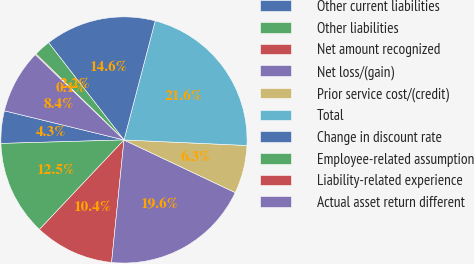Convert chart to OTSL. <chart><loc_0><loc_0><loc_500><loc_500><pie_chart><fcel>Other current liabilities<fcel>Other liabilities<fcel>Net amount recognized<fcel>Net loss/(gain)<fcel>Prior service cost/(credit)<fcel>Total<fcel>Change in discount rate<fcel>Employee-related assumption<fcel>Liability-related experience<fcel>Actual asset return different<nl><fcel>4.26%<fcel>12.5%<fcel>10.44%<fcel>19.57%<fcel>6.32%<fcel>21.63%<fcel>14.57%<fcel>2.19%<fcel>0.13%<fcel>8.38%<nl></chart> 